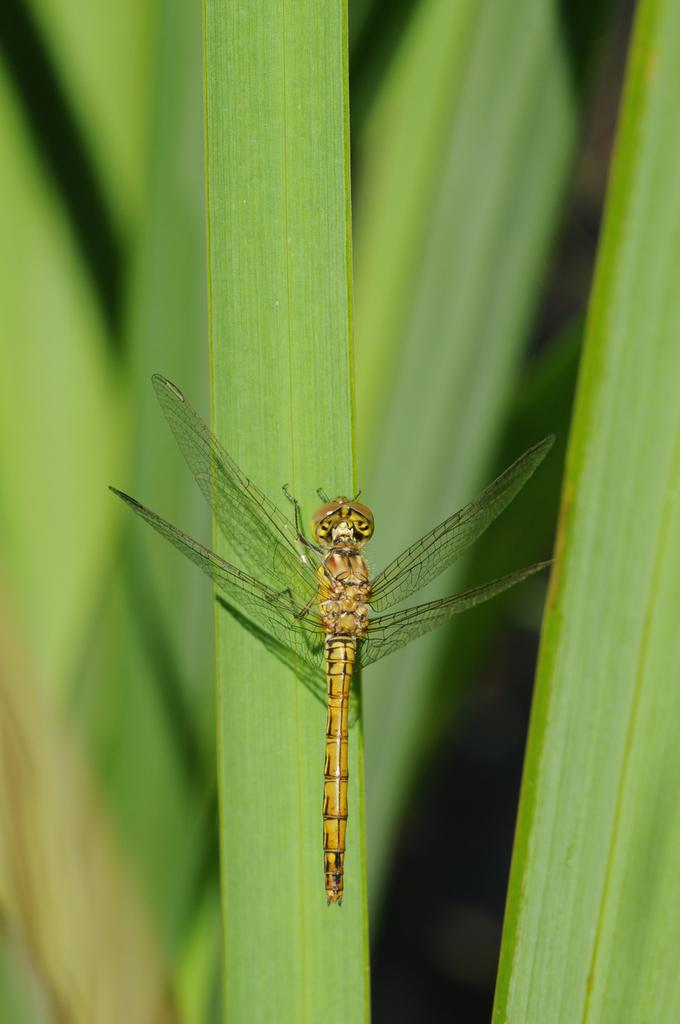What is present in the image? There is a fly in the image. Where is the fly located? The fly is on a green leaf. What type of weather can be seen in the image? There is no information about the weather in the image, as it only features a fly on a green leaf. Can you tell me if there is a cracker present in the image? There is no mention of a cracker in the image; it only contains a fly on a green leaf. 